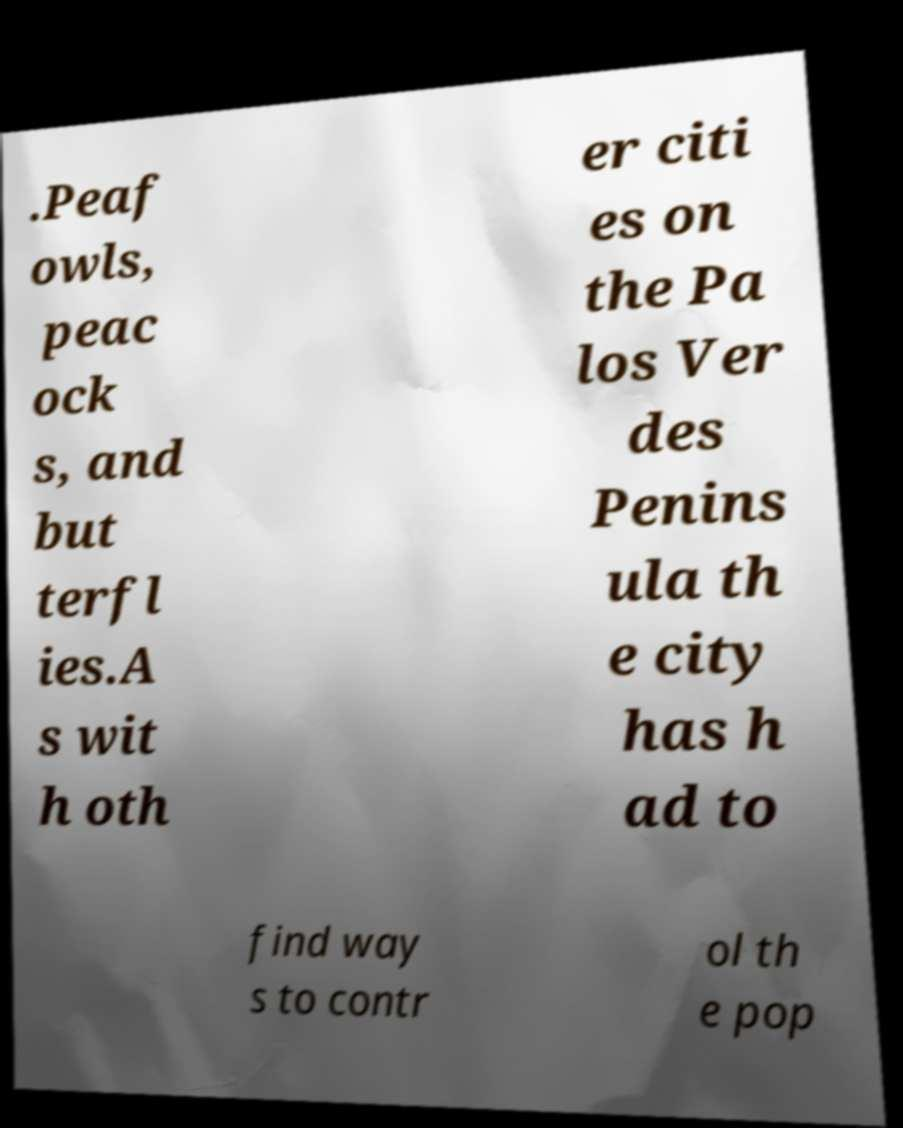Please identify and transcribe the text found in this image. .Peaf owls, peac ock s, and but terfl ies.A s wit h oth er citi es on the Pa los Ver des Penins ula th e city has h ad to find way s to contr ol th e pop 